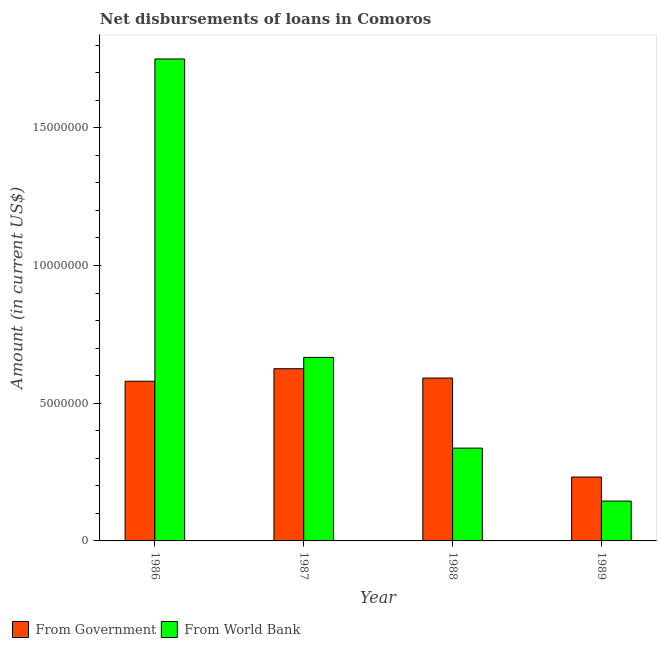How many groups of bars are there?
Ensure brevity in your answer.  4. Are the number of bars per tick equal to the number of legend labels?
Your answer should be compact. Yes. What is the label of the 1st group of bars from the left?
Your answer should be very brief. 1986. What is the net disbursements of loan from government in 1987?
Offer a terse response. 6.25e+06. Across all years, what is the maximum net disbursements of loan from world bank?
Give a very brief answer. 1.75e+07. Across all years, what is the minimum net disbursements of loan from world bank?
Offer a terse response. 1.45e+06. What is the total net disbursements of loan from government in the graph?
Your answer should be compact. 2.03e+07. What is the difference between the net disbursements of loan from world bank in 1987 and that in 1989?
Provide a succinct answer. 5.22e+06. What is the difference between the net disbursements of loan from government in 1989 and the net disbursements of loan from world bank in 1986?
Your answer should be compact. -3.48e+06. What is the average net disbursements of loan from world bank per year?
Offer a very short reply. 7.24e+06. What is the ratio of the net disbursements of loan from government in 1986 to that in 1989?
Provide a short and direct response. 2.5. Is the difference between the net disbursements of loan from government in 1987 and 1988 greater than the difference between the net disbursements of loan from world bank in 1987 and 1988?
Ensure brevity in your answer.  No. What is the difference between the highest and the second highest net disbursements of loan from government?
Offer a terse response. 3.39e+05. What is the difference between the highest and the lowest net disbursements of loan from world bank?
Give a very brief answer. 1.60e+07. In how many years, is the net disbursements of loan from government greater than the average net disbursements of loan from government taken over all years?
Offer a very short reply. 3. What does the 2nd bar from the left in 1987 represents?
Ensure brevity in your answer.  From World Bank. What does the 1st bar from the right in 1987 represents?
Give a very brief answer. From World Bank. How many bars are there?
Your response must be concise. 8. Are all the bars in the graph horizontal?
Ensure brevity in your answer.  No. What is the difference between two consecutive major ticks on the Y-axis?
Your answer should be compact. 5.00e+06. Does the graph contain any zero values?
Ensure brevity in your answer.  No. Does the graph contain grids?
Ensure brevity in your answer.  No. Where does the legend appear in the graph?
Make the answer very short. Bottom left. How many legend labels are there?
Give a very brief answer. 2. What is the title of the graph?
Your answer should be very brief. Net disbursements of loans in Comoros. What is the Amount (in current US$) in From Government in 1986?
Ensure brevity in your answer.  5.80e+06. What is the Amount (in current US$) in From World Bank in 1986?
Your answer should be very brief. 1.75e+07. What is the Amount (in current US$) in From Government in 1987?
Your response must be concise. 6.25e+06. What is the Amount (in current US$) in From World Bank in 1987?
Make the answer very short. 6.66e+06. What is the Amount (in current US$) in From Government in 1988?
Give a very brief answer. 5.91e+06. What is the Amount (in current US$) of From World Bank in 1988?
Your answer should be very brief. 3.37e+06. What is the Amount (in current US$) of From Government in 1989?
Your answer should be very brief. 2.32e+06. What is the Amount (in current US$) in From World Bank in 1989?
Your answer should be compact. 1.45e+06. Across all years, what is the maximum Amount (in current US$) in From Government?
Keep it short and to the point. 6.25e+06. Across all years, what is the maximum Amount (in current US$) of From World Bank?
Your answer should be compact. 1.75e+07. Across all years, what is the minimum Amount (in current US$) of From Government?
Your answer should be compact. 2.32e+06. Across all years, what is the minimum Amount (in current US$) of From World Bank?
Your answer should be compact. 1.45e+06. What is the total Amount (in current US$) in From Government in the graph?
Provide a succinct answer. 2.03e+07. What is the total Amount (in current US$) in From World Bank in the graph?
Your answer should be compact. 2.90e+07. What is the difference between the Amount (in current US$) in From Government in 1986 and that in 1987?
Offer a very short reply. -4.54e+05. What is the difference between the Amount (in current US$) of From World Bank in 1986 and that in 1987?
Give a very brief answer. 1.08e+07. What is the difference between the Amount (in current US$) in From Government in 1986 and that in 1988?
Make the answer very short. -1.15e+05. What is the difference between the Amount (in current US$) in From World Bank in 1986 and that in 1988?
Your answer should be compact. 1.41e+07. What is the difference between the Amount (in current US$) of From Government in 1986 and that in 1989?
Offer a terse response. 3.48e+06. What is the difference between the Amount (in current US$) of From World Bank in 1986 and that in 1989?
Your response must be concise. 1.60e+07. What is the difference between the Amount (in current US$) of From Government in 1987 and that in 1988?
Keep it short and to the point. 3.39e+05. What is the difference between the Amount (in current US$) of From World Bank in 1987 and that in 1988?
Keep it short and to the point. 3.29e+06. What is the difference between the Amount (in current US$) in From Government in 1987 and that in 1989?
Give a very brief answer. 3.93e+06. What is the difference between the Amount (in current US$) of From World Bank in 1987 and that in 1989?
Offer a very short reply. 5.22e+06. What is the difference between the Amount (in current US$) in From Government in 1988 and that in 1989?
Provide a succinct answer. 3.59e+06. What is the difference between the Amount (in current US$) in From World Bank in 1988 and that in 1989?
Provide a succinct answer. 1.92e+06. What is the difference between the Amount (in current US$) in From Government in 1986 and the Amount (in current US$) in From World Bank in 1987?
Offer a very short reply. -8.65e+05. What is the difference between the Amount (in current US$) of From Government in 1986 and the Amount (in current US$) of From World Bank in 1988?
Offer a terse response. 2.43e+06. What is the difference between the Amount (in current US$) of From Government in 1986 and the Amount (in current US$) of From World Bank in 1989?
Offer a terse response. 4.35e+06. What is the difference between the Amount (in current US$) in From Government in 1987 and the Amount (in current US$) in From World Bank in 1988?
Give a very brief answer. 2.88e+06. What is the difference between the Amount (in current US$) in From Government in 1987 and the Amount (in current US$) in From World Bank in 1989?
Give a very brief answer. 4.80e+06. What is the difference between the Amount (in current US$) of From Government in 1988 and the Amount (in current US$) of From World Bank in 1989?
Provide a short and direct response. 4.47e+06. What is the average Amount (in current US$) of From Government per year?
Provide a succinct answer. 5.07e+06. What is the average Amount (in current US$) in From World Bank per year?
Provide a short and direct response. 7.24e+06. In the year 1986, what is the difference between the Amount (in current US$) of From Government and Amount (in current US$) of From World Bank?
Offer a very short reply. -1.17e+07. In the year 1987, what is the difference between the Amount (in current US$) of From Government and Amount (in current US$) of From World Bank?
Make the answer very short. -4.11e+05. In the year 1988, what is the difference between the Amount (in current US$) in From Government and Amount (in current US$) in From World Bank?
Offer a terse response. 2.54e+06. In the year 1989, what is the difference between the Amount (in current US$) in From Government and Amount (in current US$) in From World Bank?
Offer a very short reply. 8.72e+05. What is the ratio of the Amount (in current US$) of From Government in 1986 to that in 1987?
Provide a succinct answer. 0.93. What is the ratio of the Amount (in current US$) in From World Bank in 1986 to that in 1987?
Your response must be concise. 2.63. What is the ratio of the Amount (in current US$) of From Government in 1986 to that in 1988?
Provide a succinct answer. 0.98. What is the ratio of the Amount (in current US$) in From World Bank in 1986 to that in 1988?
Make the answer very short. 5.19. What is the ratio of the Amount (in current US$) of From Government in 1986 to that in 1989?
Make the answer very short. 2.5. What is the ratio of the Amount (in current US$) in From World Bank in 1986 to that in 1989?
Your response must be concise. 12.09. What is the ratio of the Amount (in current US$) in From Government in 1987 to that in 1988?
Provide a short and direct response. 1.06. What is the ratio of the Amount (in current US$) in From World Bank in 1987 to that in 1988?
Your answer should be very brief. 1.98. What is the ratio of the Amount (in current US$) in From Government in 1987 to that in 1989?
Ensure brevity in your answer.  2.7. What is the ratio of the Amount (in current US$) of From World Bank in 1987 to that in 1989?
Offer a terse response. 4.6. What is the ratio of the Amount (in current US$) of From Government in 1988 to that in 1989?
Provide a succinct answer. 2.55. What is the ratio of the Amount (in current US$) in From World Bank in 1988 to that in 1989?
Provide a short and direct response. 2.33. What is the difference between the highest and the second highest Amount (in current US$) of From Government?
Your response must be concise. 3.39e+05. What is the difference between the highest and the second highest Amount (in current US$) of From World Bank?
Keep it short and to the point. 1.08e+07. What is the difference between the highest and the lowest Amount (in current US$) in From Government?
Ensure brevity in your answer.  3.93e+06. What is the difference between the highest and the lowest Amount (in current US$) in From World Bank?
Your answer should be very brief. 1.60e+07. 